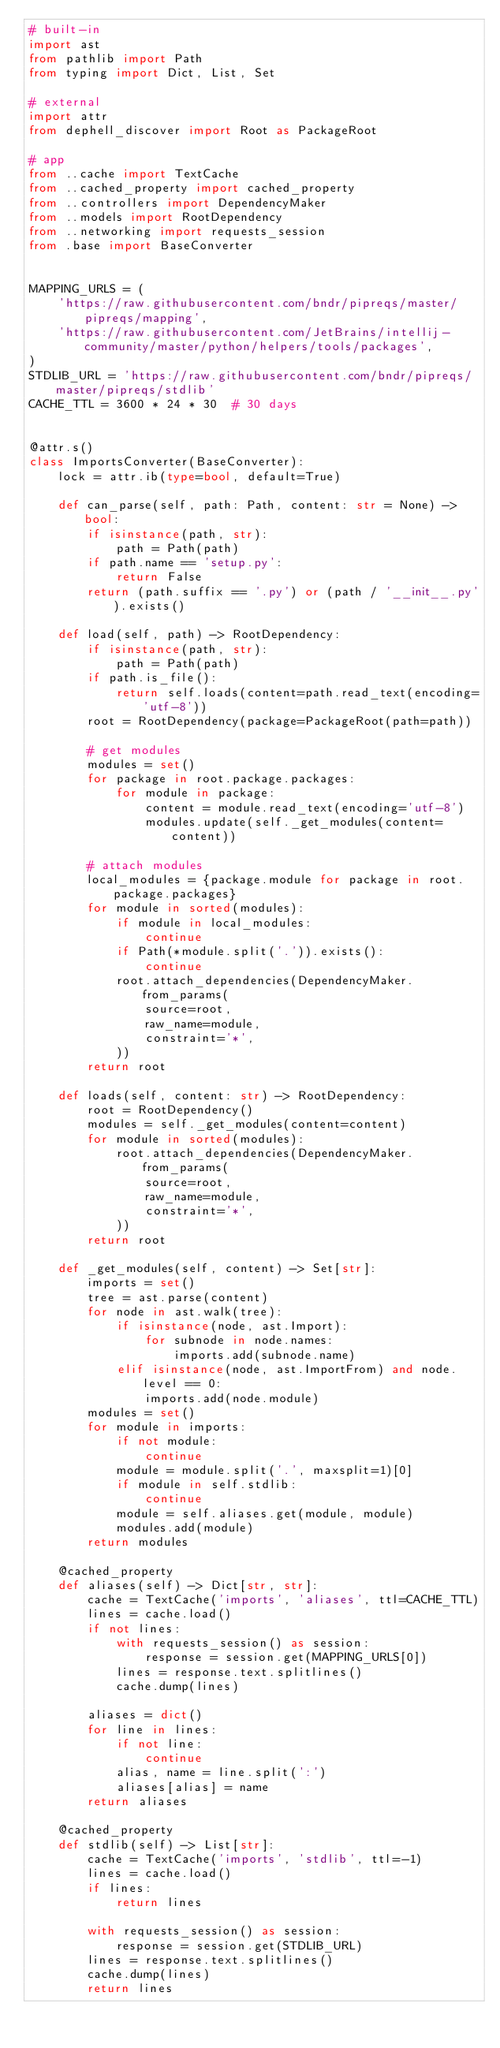<code> <loc_0><loc_0><loc_500><loc_500><_Python_># built-in
import ast
from pathlib import Path
from typing import Dict, List, Set

# external
import attr
from dephell_discover import Root as PackageRoot

# app
from ..cache import TextCache
from ..cached_property import cached_property
from ..controllers import DependencyMaker
from ..models import RootDependency
from ..networking import requests_session
from .base import BaseConverter


MAPPING_URLS = (
    'https://raw.githubusercontent.com/bndr/pipreqs/master/pipreqs/mapping',
    'https://raw.githubusercontent.com/JetBrains/intellij-community/master/python/helpers/tools/packages',
)
STDLIB_URL = 'https://raw.githubusercontent.com/bndr/pipreqs/master/pipreqs/stdlib'
CACHE_TTL = 3600 * 24 * 30  # 30 days


@attr.s()
class ImportsConverter(BaseConverter):
    lock = attr.ib(type=bool, default=True)

    def can_parse(self, path: Path, content: str = None) -> bool:
        if isinstance(path, str):
            path = Path(path)
        if path.name == 'setup.py':
            return False
        return (path.suffix == '.py') or (path / '__init__.py').exists()

    def load(self, path) -> RootDependency:
        if isinstance(path, str):
            path = Path(path)
        if path.is_file():
            return self.loads(content=path.read_text(encoding='utf-8'))
        root = RootDependency(package=PackageRoot(path=path))

        # get modules
        modules = set()
        for package in root.package.packages:
            for module in package:
                content = module.read_text(encoding='utf-8')
                modules.update(self._get_modules(content=content))

        # attach modules
        local_modules = {package.module for package in root.package.packages}
        for module in sorted(modules):
            if module in local_modules:
                continue
            if Path(*module.split('.')).exists():
                continue
            root.attach_dependencies(DependencyMaker.from_params(
                source=root,
                raw_name=module,
                constraint='*',
            ))
        return root

    def loads(self, content: str) -> RootDependency:
        root = RootDependency()
        modules = self._get_modules(content=content)
        for module in sorted(modules):
            root.attach_dependencies(DependencyMaker.from_params(
                source=root,
                raw_name=module,
                constraint='*',
            ))
        return root

    def _get_modules(self, content) -> Set[str]:
        imports = set()
        tree = ast.parse(content)
        for node in ast.walk(tree):
            if isinstance(node, ast.Import):
                for subnode in node.names:
                    imports.add(subnode.name)
            elif isinstance(node, ast.ImportFrom) and node.level == 0:
                imports.add(node.module)
        modules = set()
        for module in imports:
            if not module:
                continue
            module = module.split('.', maxsplit=1)[0]
            if module in self.stdlib:
                continue
            module = self.aliases.get(module, module)
            modules.add(module)
        return modules

    @cached_property
    def aliases(self) -> Dict[str, str]:
        cache = TextCache('imports', 'aliases', ttl=CACHE_TTL)
        lines = cache.load()
        if not lines:
            with requests_session() as session:
                response = session.get(MAPPING_URLS[0])
            lines = response.text.splitlines()
            cache.dump(lines)

        aliases = dict()
        for line in lines:
            if not line:
                continue
            alias, name = line.split(':')
            aliases[alias] = name
        return aliases

    @cached_property
    def stdlib(self) -> List[str]:
        cache = TextCache('imports', 'stdlib', ttl=-1)
        lines = cache.load()
        if lines:
            return lines

        with requests_session() as session:
            response = session.get(STDLIB_URL)
        lines = response.text.splitlines()
        cache.dump(lines)
        return lines
</code> 